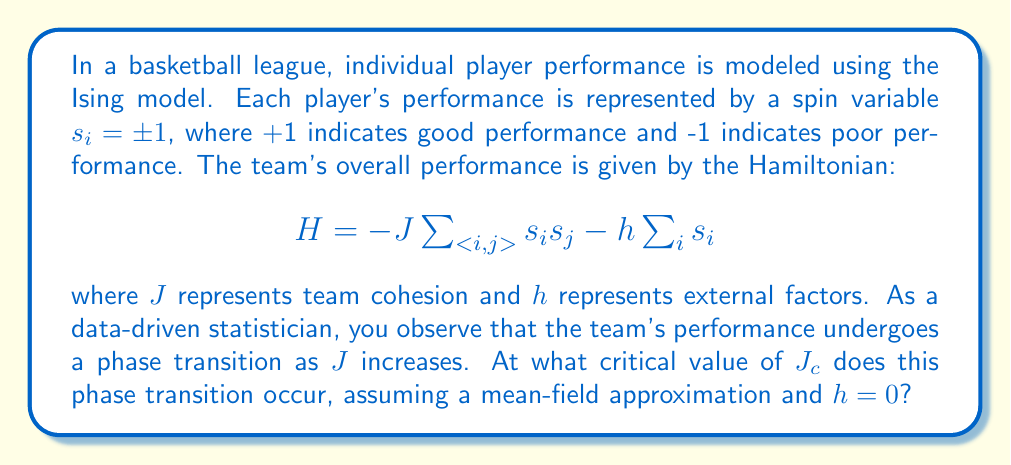Can you solve this math problem? To solve this problem, we'll use the mean-field approximation of the Ising model:

1) In the mean-field theory, we assume each spin interacts with the average field of all other spins. Let $m = \langle s_i \rangle$ be the average magnetization (team performance).

2) The effective field experienced by each spin is:

   $$h_{eff} = zJm + h$$

   where $z$ is the number of nearest neighbors (we can assume $z=N-1$ for a fully connected team of $N$ players).

3) The self-consistent equation for magnetization is:

   $$m = \tanh(\beta h_{eff}) = \tanh(\beta zJm + \beta h)$$

   where $\beta = 1/(k_BT)$, $k_B$ is Boltzmann's constant, and $T$ is temperature.

4) For $h=0$, this simplifies to:

   $$m = \tanh(\beta zJm)$$

5) The phase transition occurs when a non-zero solution for $m$ first appears. This happens when the slope of $\tanh(\beta zJm)$ at $m=0$ equals 1:

   $$\left.\frac{d}{dm}\tanh(\beta zJm)\right|_{m=0} = \beta zJ = 1$$

6) Solving for $J$:

   $$J_c = \frac{1}{\beta z} = \frac{k_BT}{z}$$

7) In the context of our problem, we can interpret $T$ as a measure of randomness in individual performances. The critical value $J_c$ represents the minimum level of team cohesion needed to overcome this randomness and achieve coordinated team performance.
Answer: $J_c = \frac{k_BT}{z}$ 